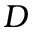Convert formula to latex. <formula><loc_0><loc_0><loc_500><loc_500>D</formula> 